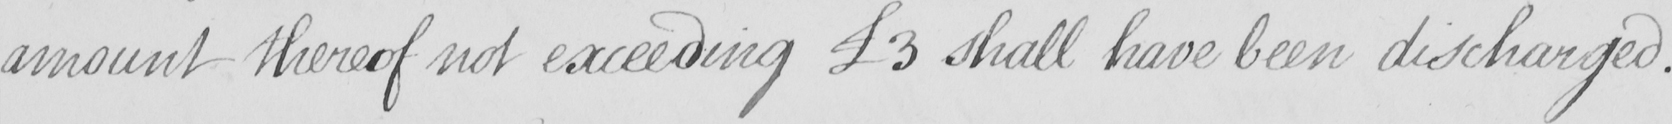What text is written in this handwritten line? amount thereof not exceeding  £3 shall have been discharged . 